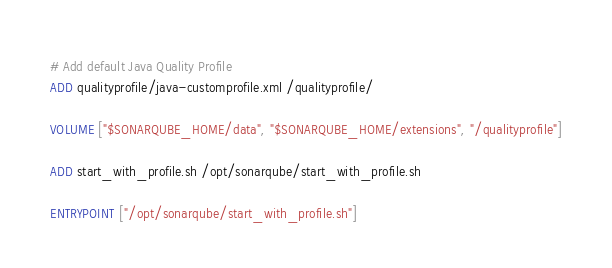Convert code to text. <code><loc_0><loc_0><loc_500><loc_500><_Dockerfile_># Add default Java Quality Profile
ADD qualityprofile/java-customprofile.xml /qualityprofile/

VOLUME ["$SONARQUBE_HOME/data", "$SONARQUBE_HOME/extensions", "/qualityprofile"]

ADD start_with_profile.sh /opt/sonarqube/start_with_profile.sh

ENTRYPOINT ["/opt/sonarqube/start_with_profile.sh"]
</code> 